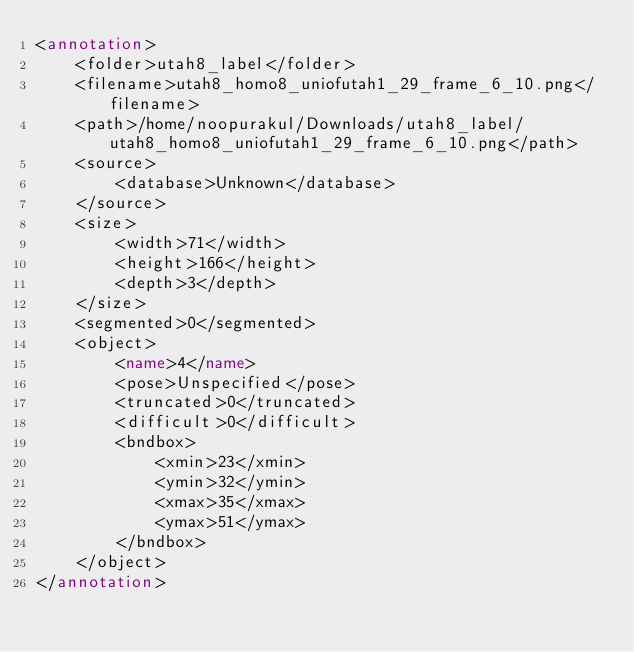Convert code to text. <code><loc_0><loc_0><loc_500><loc_500><_XML_><annotation>
	<folder>utah8_label</folder>
	<filename>utah8_homo8_uniofutah1_29_frame_6_10.png</filename>
	<path>/home/noopurakul/Downloads/utah8_label/utah8_homo8_uniofutah1_29_frame_6_10.png</path>
	<source>
		<database>Unknown</database>
	</source>
	<size>
		<width>71</width>
		<height>166</height>
		<depth>3</depth>
	</size>
	<segmented>0</segmented>
	<object>
		<name>4</name>
		<pose>Unspecified</pose>
		<truncated>0</truncated>
		<difficult>0</difficult>
		<bndbox>
			<xmin>23</xmin>
			<ymin>32</ymin>
			<xmax>35</xmax>
			<ymax>51</ymax>
		</bndbox>
	</object>
</annotation>
</code> 